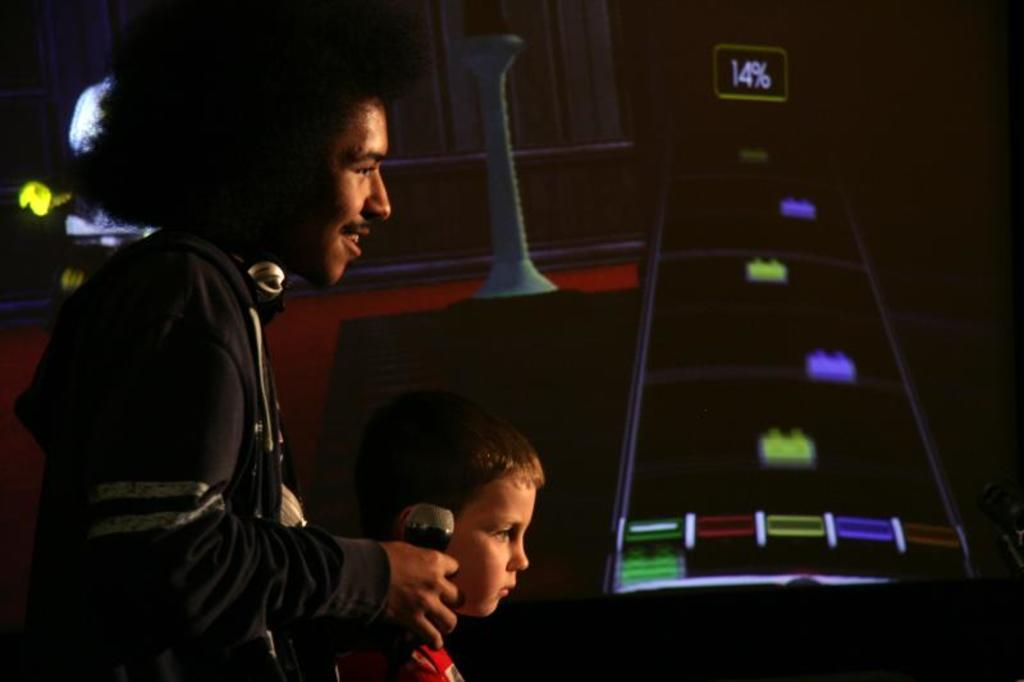What is the man in the image wearing? The man is wearing a black jacket. What is the man holding in the image? The man is holding a microphone. Who else is present in the image? There is a boy in the image. What is the boy doing in the image? The boy is standing. What can be seen in the background of the image? There is a board and a pole in the background of the image. What color is the grape that the man is holding in the image? There is no grape present in the image; the man is holding a microphone. What is the man's interest in the image? The provided facts do not mention the man's interests, so we cannot determine his interest from the image. 